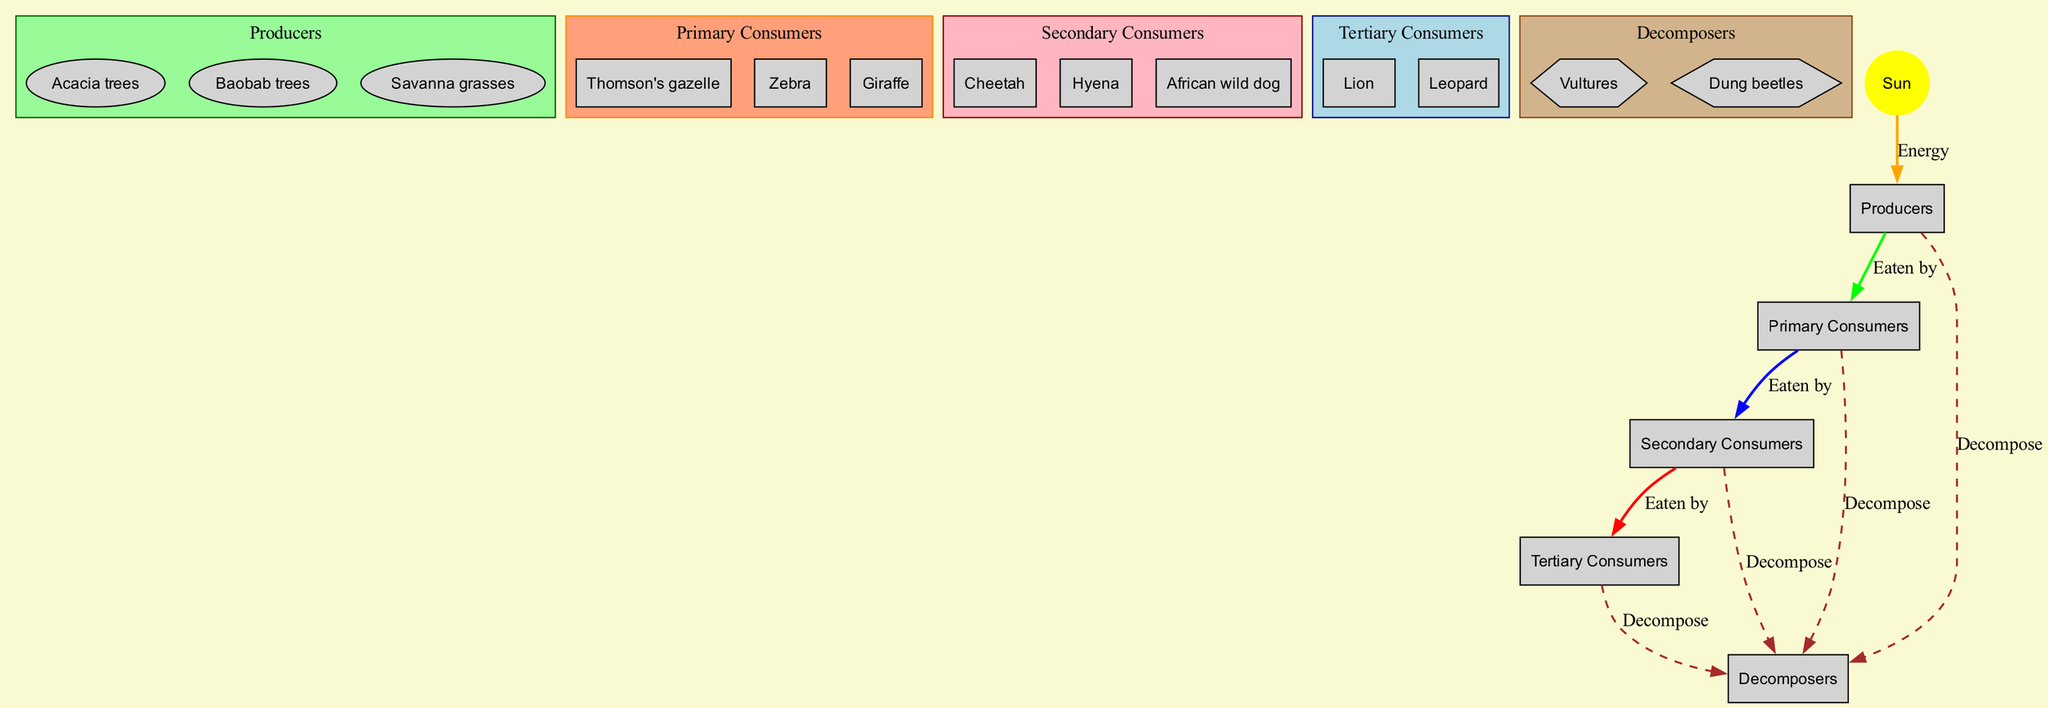What are the producers in the Savanna food chain? The producers listed in the diagram are Acacia trees, Baobab trees, and Savanna grasses. This can be easily identified by looking at the "Producers" section of the diagram.
Answer: Acacia trees, Baobab trees, Savanna grasses How many primary consumers are there? By counting the nodes in the "Primary Consumers" section, we find Thomson's gazelle, Zebra, and Giraffe, totaling three primary consumers.
Answer: 3 Which consumer is at the top of the food chain? The top consumers are the tertiary consumers, which are Lion and Leopard. Since Lion is first in the order listed, it can be considered the top.
Answer: Lion What do secondary consumers eat? Secondary consumers, which include Cheetah, Hyena, and African wild dog, are indicated to eat primary consumers. This relationship is explicitly mentioned in the diagram.
Answer: Primary consumers Which organisms are considered decomposers? The diagram identifies decomposers as Vultures and Dung beetles, found in the "Decomposers" section of the diagram.
Answer: Vultures, Dung beetles How does energy flow from the Sun to producers? The diagram shows a direct edge labeled 'Energy' from the Sun to the 'Producers' node, indicating that energy from the sun is essential for producing organisms to thrive.
Answer: Energy What is the relationship between producers and primary consumers? The relationship is indicated by an edge labeled 'Eaten by' connecting producers to primary consumers, demonstrating that primary consumers rely on producers for food.
Answer: Eaten by What process connects all levels to decomposers? The diagram indicates a dashed edge labeled 'Decompose' connecting all consumer levels to decomposers, illustrating how all organisms eventually return nutrients to the ecosystem through decomposition.
Answer: Decompose 